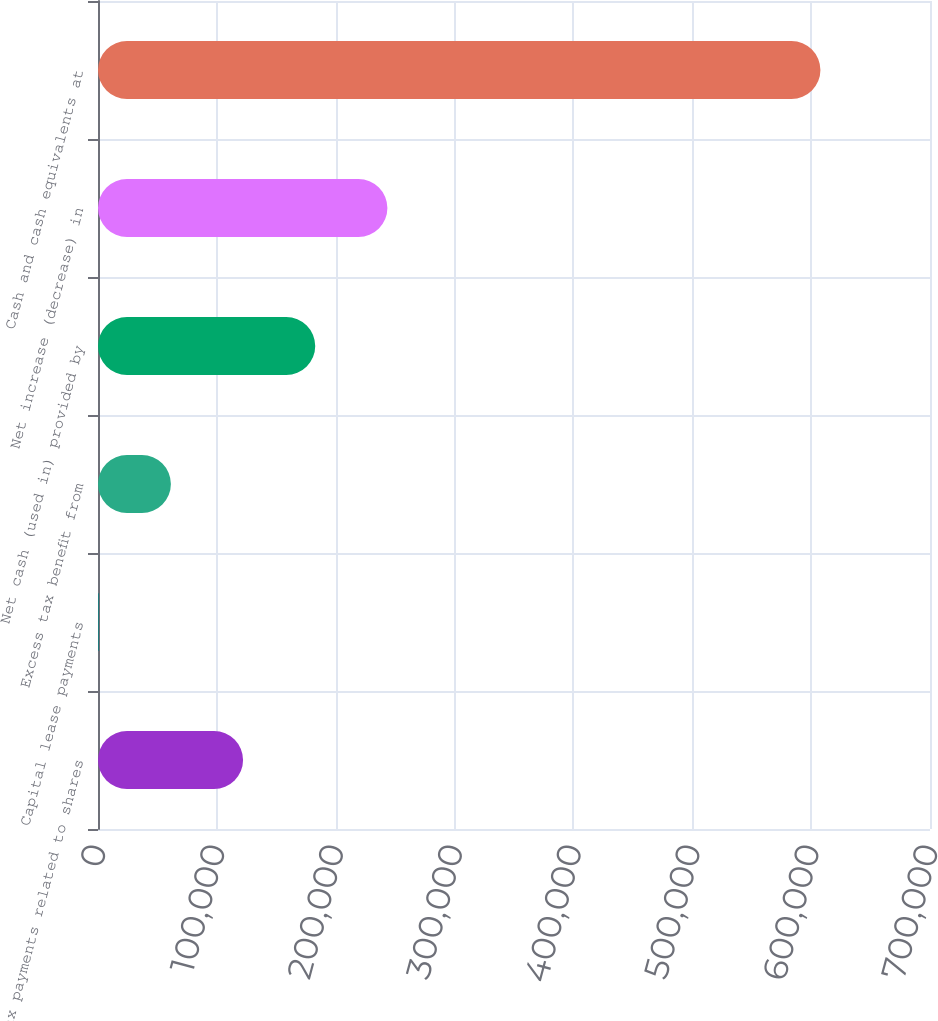<chart> <loc_0><loc_0><loc_500><loc_500><bar_chart><fcel>Tax payments related to shares<fcel>Capital lease payments<fcel>Excess tax benefit from<fcel>Net cash (used in) provided by<fcel>Net increase (decrease) in<fcel>Cash and cash equivalents at<nl><fcel>122046<fcel>604<fcel>61325.1<fcel>182767<fcel>243488<fcel>607815<nl></chart> 